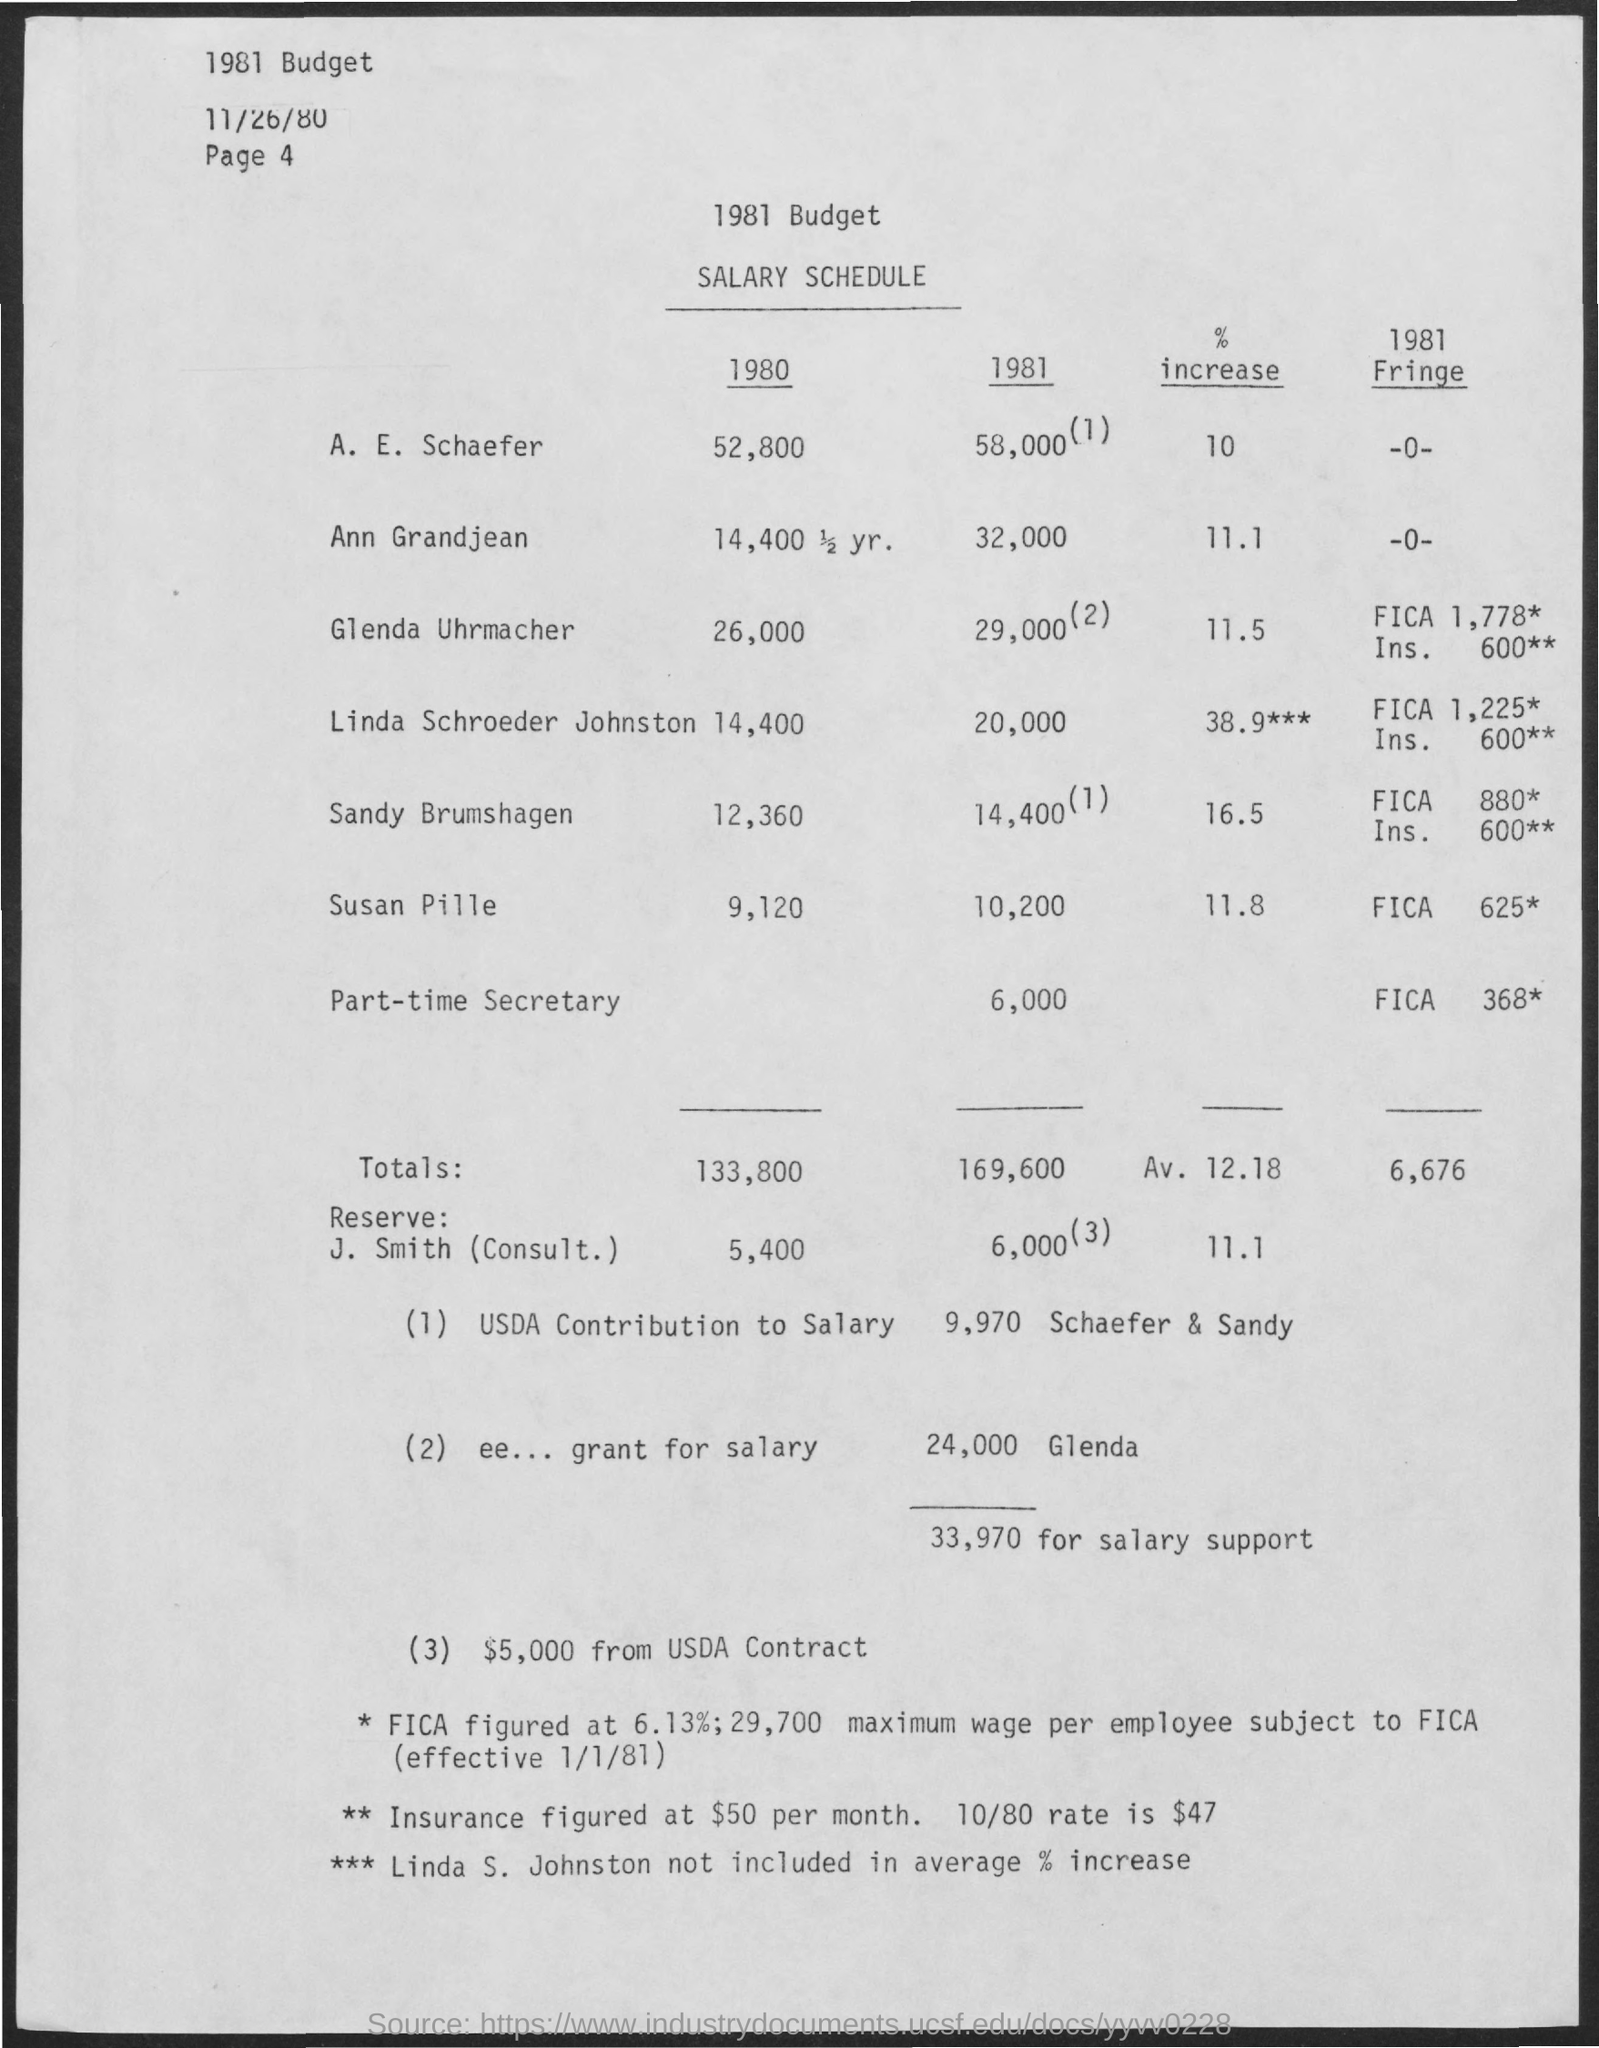Salary of A.E. Schaefer in the year 1980?
Your answer should be very brief. 52,800. What is the % increase of salary of Ann Grandjean?
Your answer should be very brief. 11.1. 